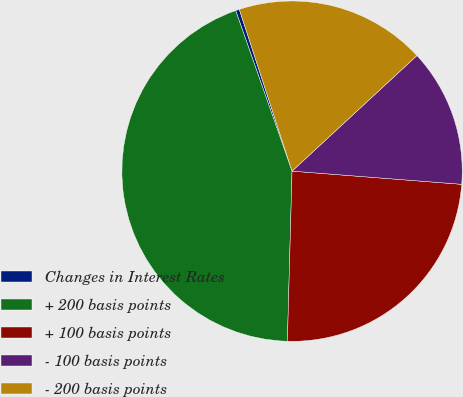Convert chart to OTSL. <chart><loc_0><loc_0><loc_500><loc_500><pie_chart><fcel>Changes in Interest Rates<fcel>+ 200 basis points<fcel>+ 100 basis points<fcel>- 100 basis points<fcel>- 200 basis points<nl><fcel>0.36%<fcel>44.19%<fcel>24.2%<fcel>13.12%<fcel>18.13%<nl></chart> 